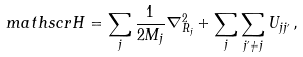Convert formula to latex. <formula><loc_0><loc_0><loc_500><loc_500>\ m a t h s c r { H } = \sum _ { j } \frac { 1 } { 2 M _ { j } } \nabla ^ { 2 } _ { R _ { j } } + \sum _ { j } \sum _ { j ^ { \prime } \neq j } U _ { j j ^ { \prime } } \, ,</formula> 